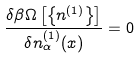Convert formula to latex. <formula><loc_0><loc_0><loc_500><loc_500>\frac { \delta \beta \Omega \left [ \left \{ n ^ { ( 1 ) } \right \} \right ] } { \delta n _ { \alpha } ^ { ( 1 ) } ( { x } ) } = 0</formula> 